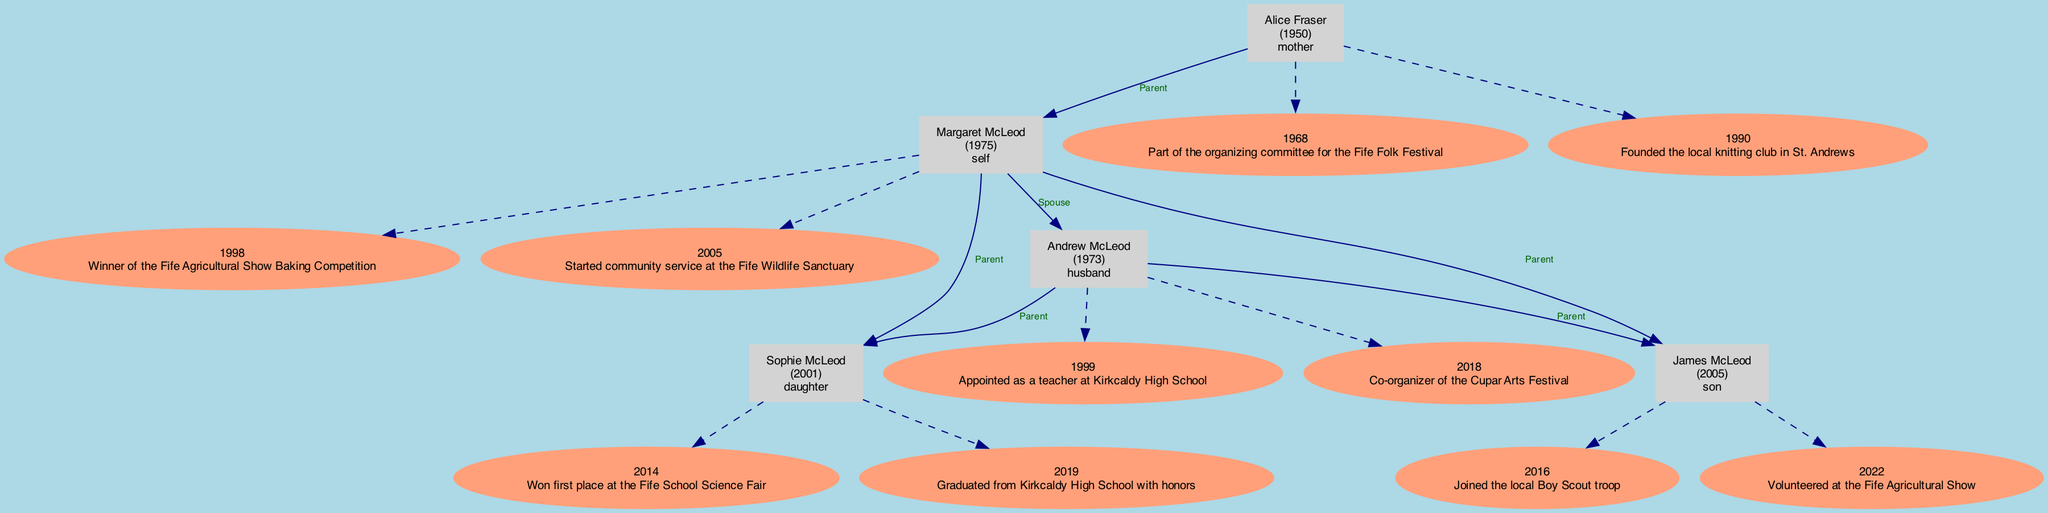What year did Margaret McLeod win the baking competition? The diagram shows that Margaret McLeod won the Fife Agricultural Show Baking Competition in 1998. This is found under her historical events section.
Answer: 1998 Who is Andrew McLeod's spouse? The diagram indicates that Andrew McLeod's spouse is Margaret McLeod, as there is a direct edge labeled 'Spouse' connecting them.
Answer: Margaret McLeod Which event did James McLeod volunteer at? The diagram shows that James McLeod volunteered at the Fife Agricultural Show in 2022, which is listed under his historical events.
Answer: Fife Agricultural Show How many nodes are present in total? By counting the family members and their associated historical event nodes in the diagram, there are 11 nodes in total. Each family member has at least one historical event node connected to them.
Answer: 11 What is Alice Fraser's notable contribution in 1968? The diagram indicates that Alice Fraser was part of the organizing committee for the Fife Folk Festival in 1968 listed under her historical events.
Answer: Fife Folk Festival Which child of Margaret McLeod graduated with honors? The diagram specifies that Sophie McLeod graduated from Kirkcaldy High School with honors in 2019, found under her historical events section.
Answer: Sophie McLeod What relationship is James McLeod to Margaret McLeod? The diagram directly shows that James McLeod is the son of Margaret McLeod, indicated by the edge labeled 'Parent.'
Answer: Son In what year did Andrew McLeod co-organize the Cupar Arts Festival? The diagram indicates that Andrew McLeod co-organized the Cupar Arts Festival in 2018, which is documented under his historical events.
Answer: 2018 How many parents does Margaret McLeod have shown in the diagram? The diagram shows that Margaret McLeod has one parent, Alice Fraser, who is connected with an edge labeled 'Parent.'
Answer: 1 